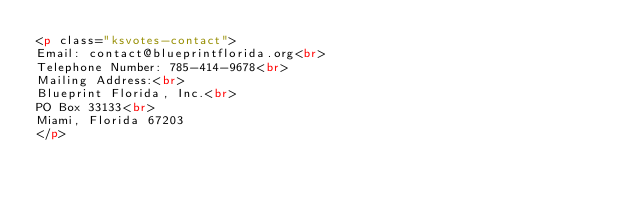Convert code to text. <code><loc_0><loc_0><loc_500><loc_500><_HTML_><p class="ksvotes-contact">
Email: contact@blueprintflorida.org<br>
Telephone Number: 785-414-9678<br>
Mailing Address:<br>
Blueprint Florida, Inc.<br>
PO Box 33133<br>
Miami, Florida 67203
</p>
</code> 